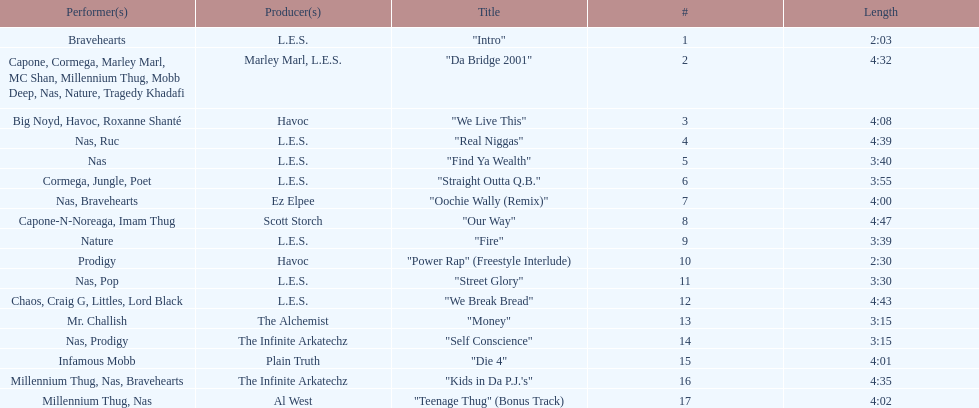How long is each song? 2:03, 4:32, 4:08, 4:39, 3:40, 3:55, 4:00, 4:47, 3:39, 2:30, 3:30, 4:43, 3:15, 3:15, 4:01, 4:35, 4:02. Of those, which length is the shortest? 2:03. 